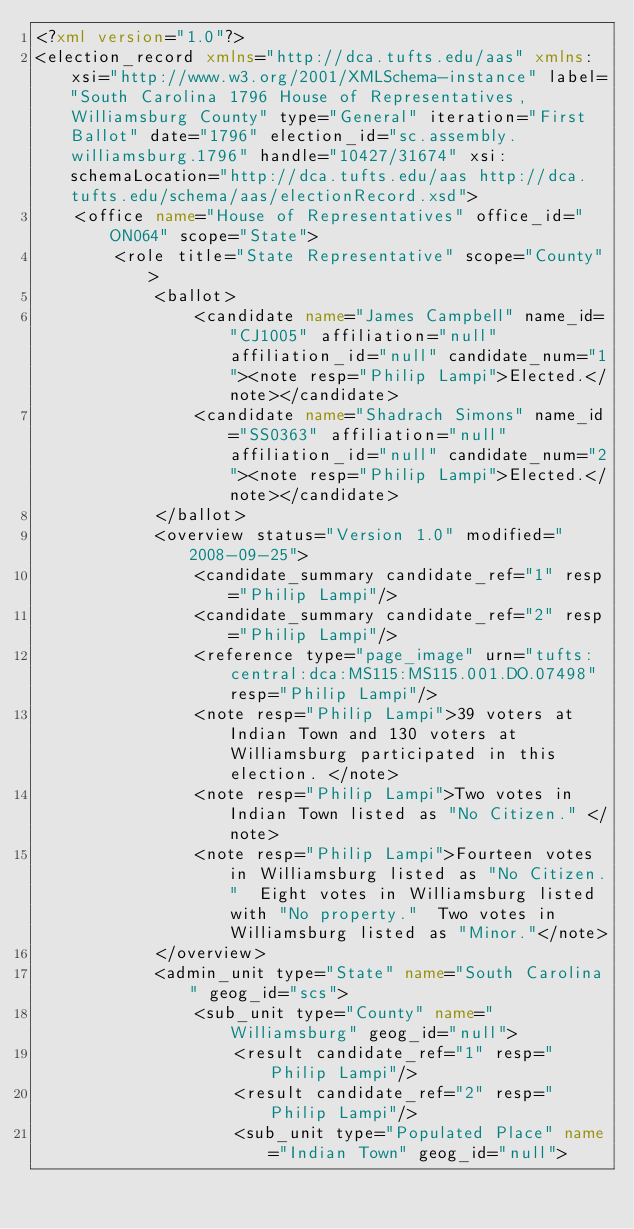Convert code to text. <code><loc_0><loc_0><loc_500><loc_500><_XML_><?xml version="1.0"?>
<election_record xmlns="http://dca.tufts.edu/aas" xmlns:xsi="http://www.w3.org/2001/XMLSchema-instance" label="South Carolina 1796 House of Representatives, Williamsburg County" type="General" iteration="First Ballot" date="1796" election_id="sc.assembly.williamsburg.1796" handle="10427/31674" xsi:schemaLocation="http://dca.tufts.edu/aas http://dca.tufts.edu/schema/aas/electionRecord.xsd">
	<office name="House of Representatives" office_id="ON064" scope="State">
		<role title="State Representative" scope="County">
			<ballot>
				<candidate name="James Campbell" name_id="CJ1005" affiliation="null" affiliation_id="null" candidate_num="1"><note resp="Philip Lampi">Elected.</note></candidate>
				<candidate name="Shadrach Simons" name_id="SS0363" affiliation="null" affiliation_id="null" candidate_num="2"><note resp="Philip Lampi">Elected.</note></candidate>
			</ballot>
			<overview status="Version 1.0" modified="2008-09-25">
				<candidate_summary candidate_ref="1" resp="Philip Lampi"/>
				<candidate_summary candidate_ref="2" resp="Philip Lampi"/>
				<reference type="page_image" urn="tufts:central:dca:MS115:MS115.001.DO.07498" resp="Philip Lampi"/>
				<note resp="Philip Lampi">39 voters at Indian Town and 130 voters at Williamsburg participated in this election. </note>
				<note resp="Philip Lampi">Two votes in Indian Town listed as "No Citizen." </note>
				<note resp="Philip Lampi">Fourteen votes in Williamsburg listed as "No Citizen."  Eight votes in Williamsburg listed with "No property."  Two votes in Williamsburg listed as "Minor."</note>
			</overview>
			<admin_unit type="State" name="South Carolina" geog_id="scs">
				<sub_unit type="County" name="Williamsburg" geog_id="null">
					<result candidate_ref="1" resp="Philip Lampi"/>
					<result candidate_ref="2" resp="Philip Lampi"/>
					<sub_unit type="Populated Place" name="Indian Town" geog_id="null"></code> 